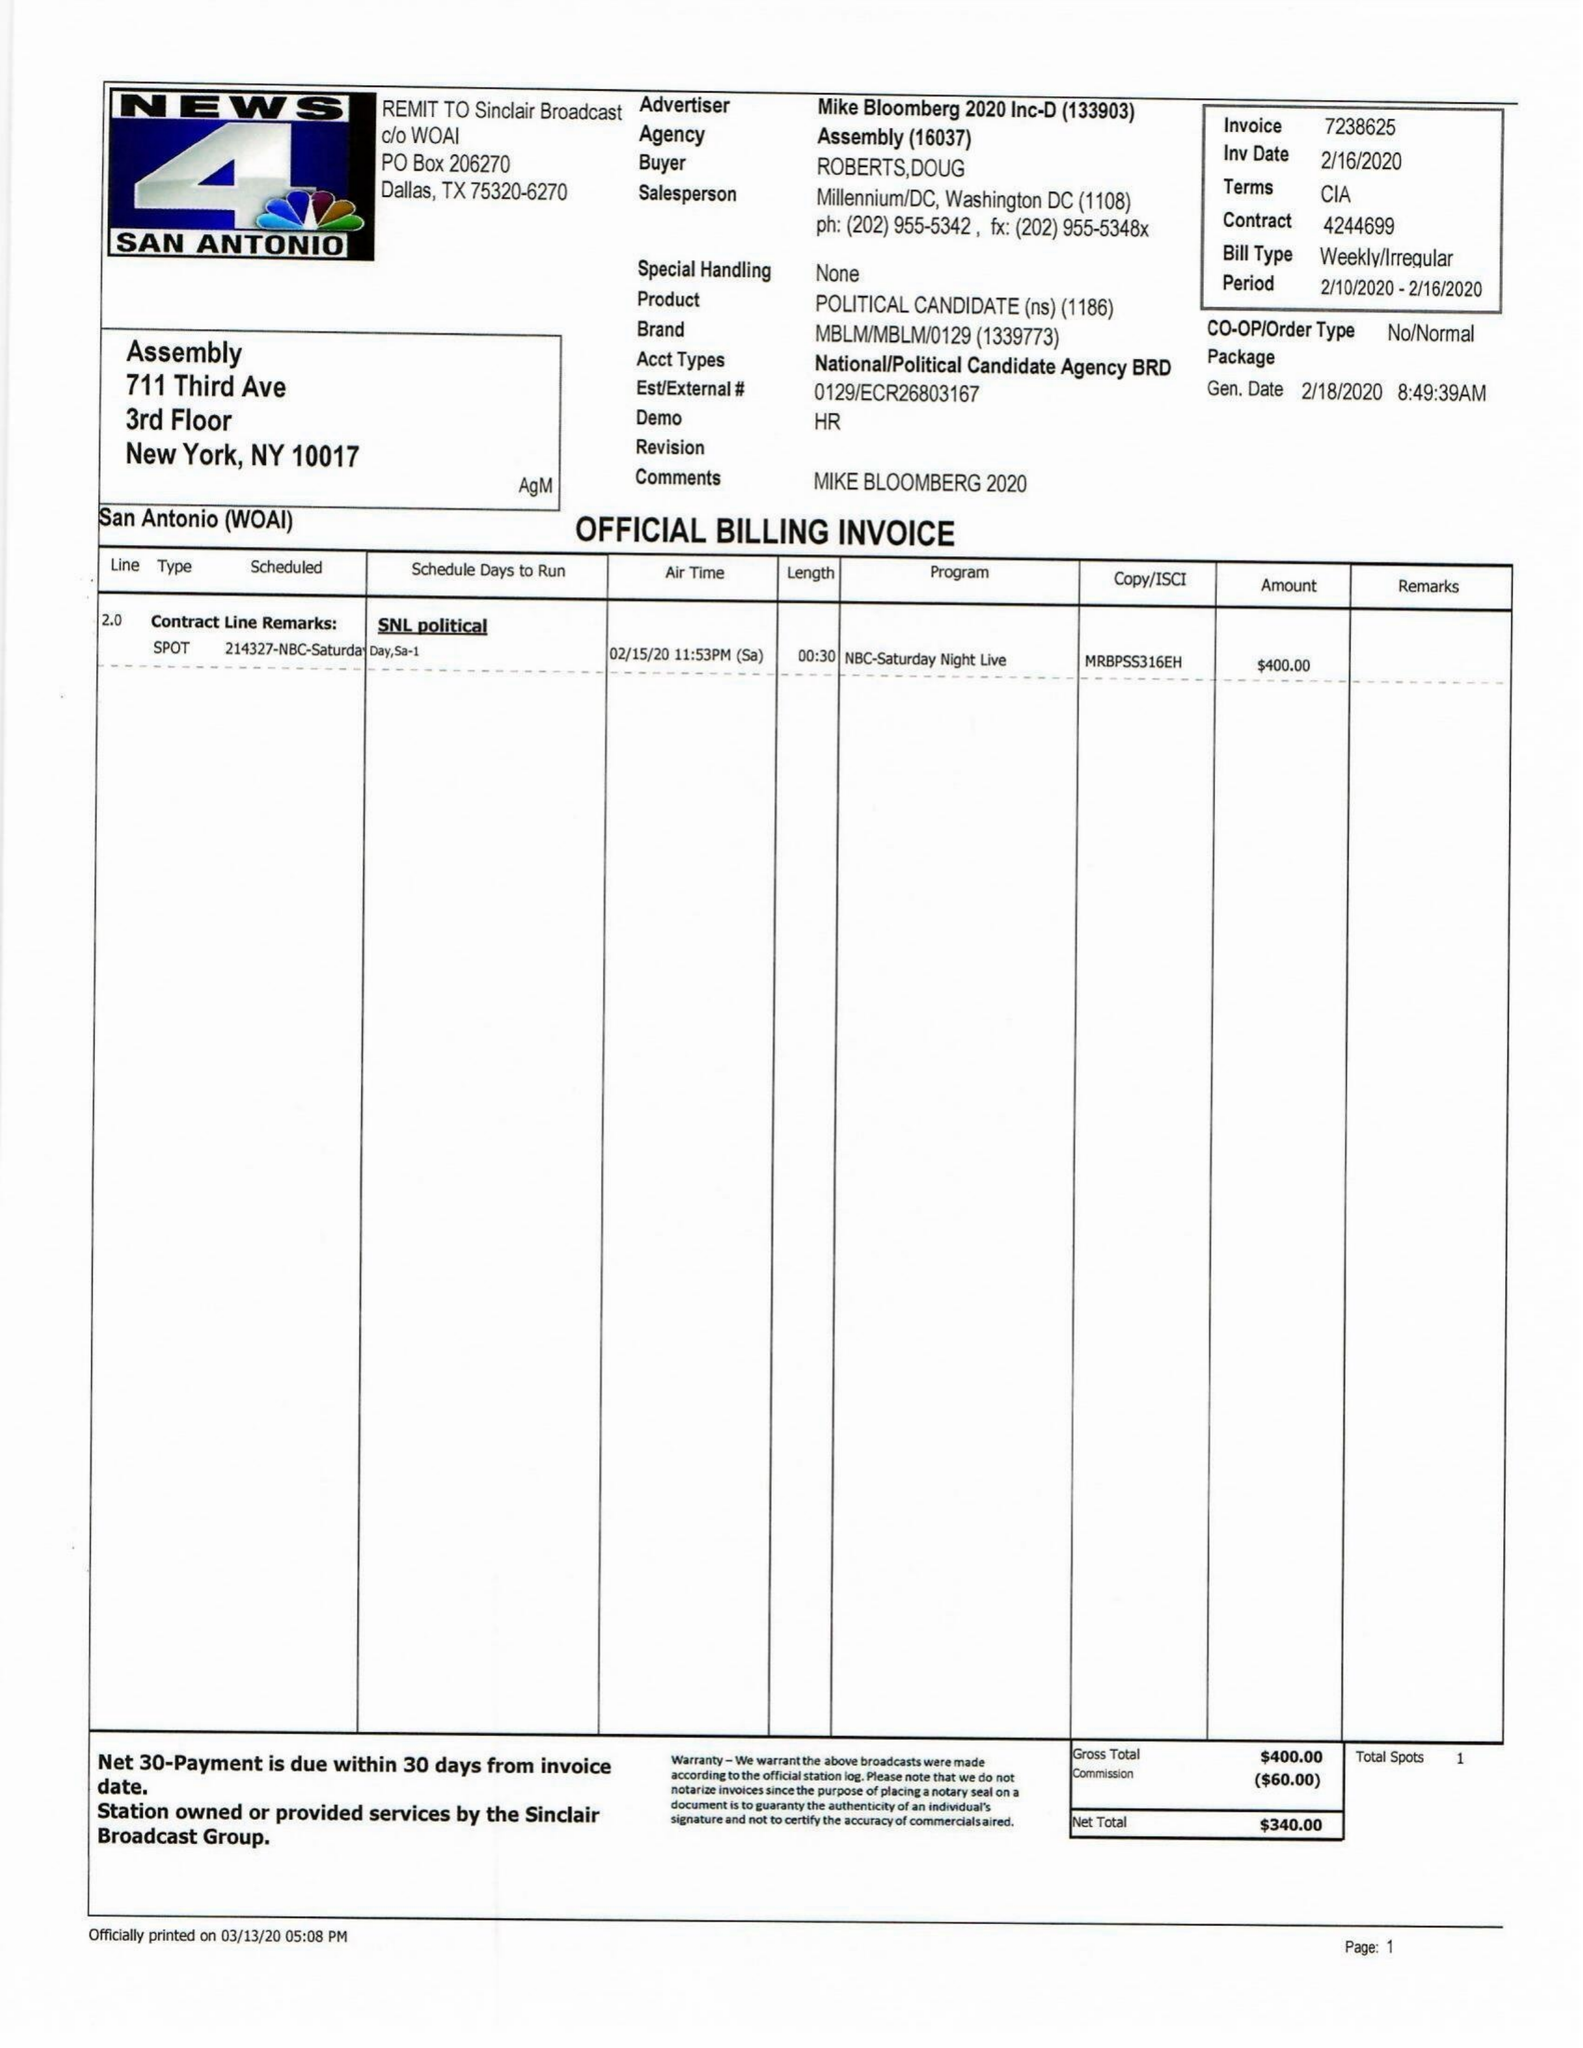What is the value for the flight_from?
Answer the question using a single word or phrase. 02/10/20 